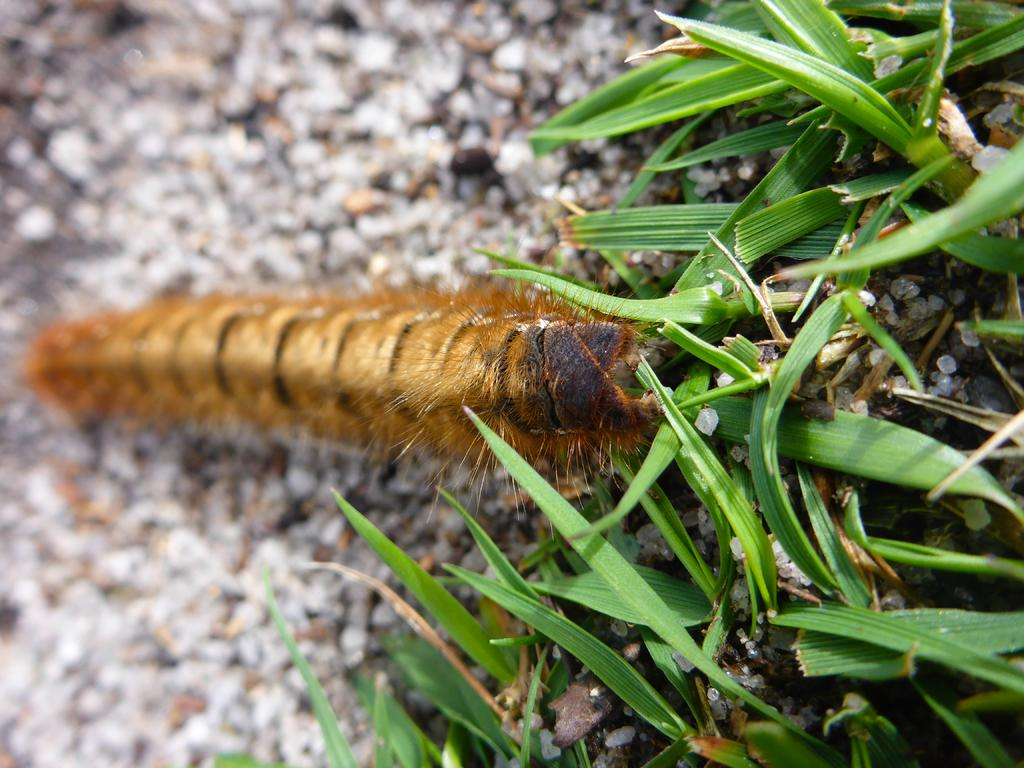What is on the ground in the image? There is a caterpillar on the ground in the image. What can be seen on the right side of the image? There are plants on the right side of the image. What is the value of the silver thing in the image? There is no silver thing present in the image. 